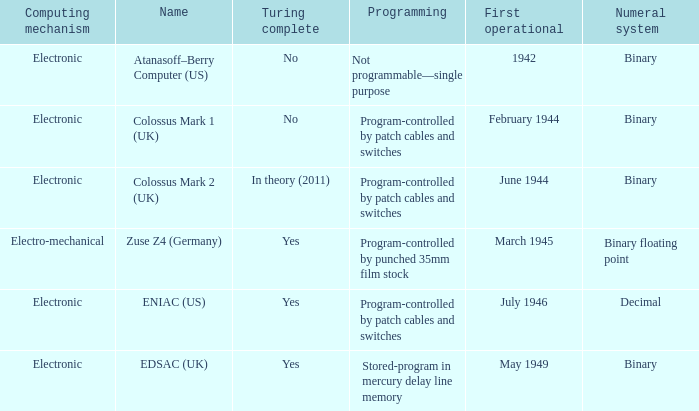What's the turing complete with name being atanasoff–berry computer (us) No. 